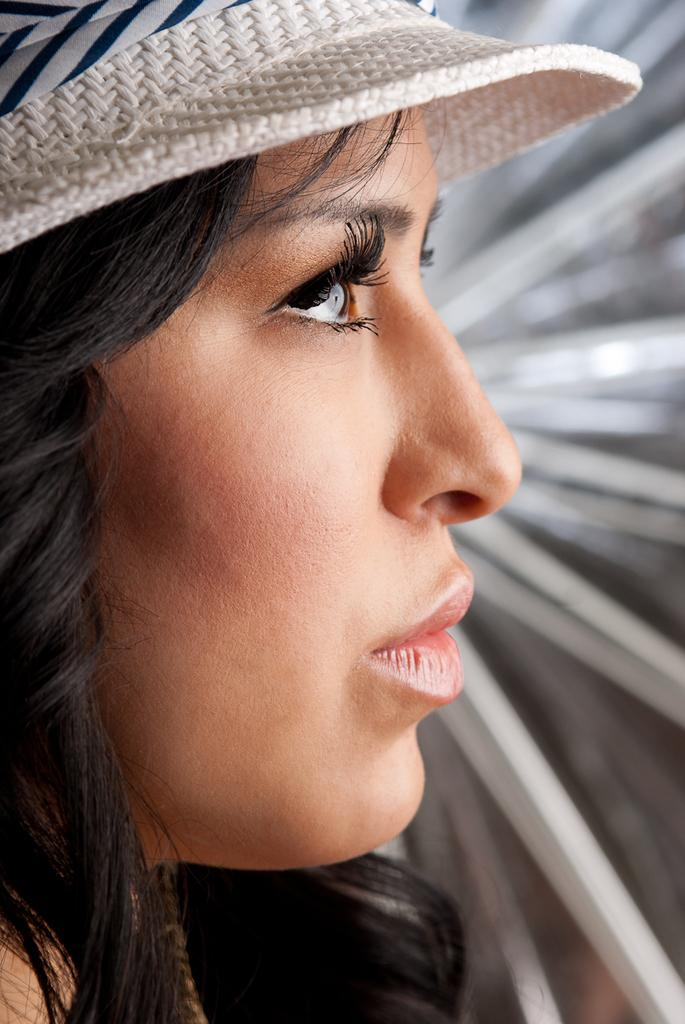What is the main subject of the image? The main subject of the image is a woman. What is the woman wearing on her head? The woman is wearing a hat. Can you describe the background of the image? The background of the image is blurred. How many leaves can be seen falling in the image? There are no leaves present in the image, as it features a woman wearing a hat with a blurred background. 